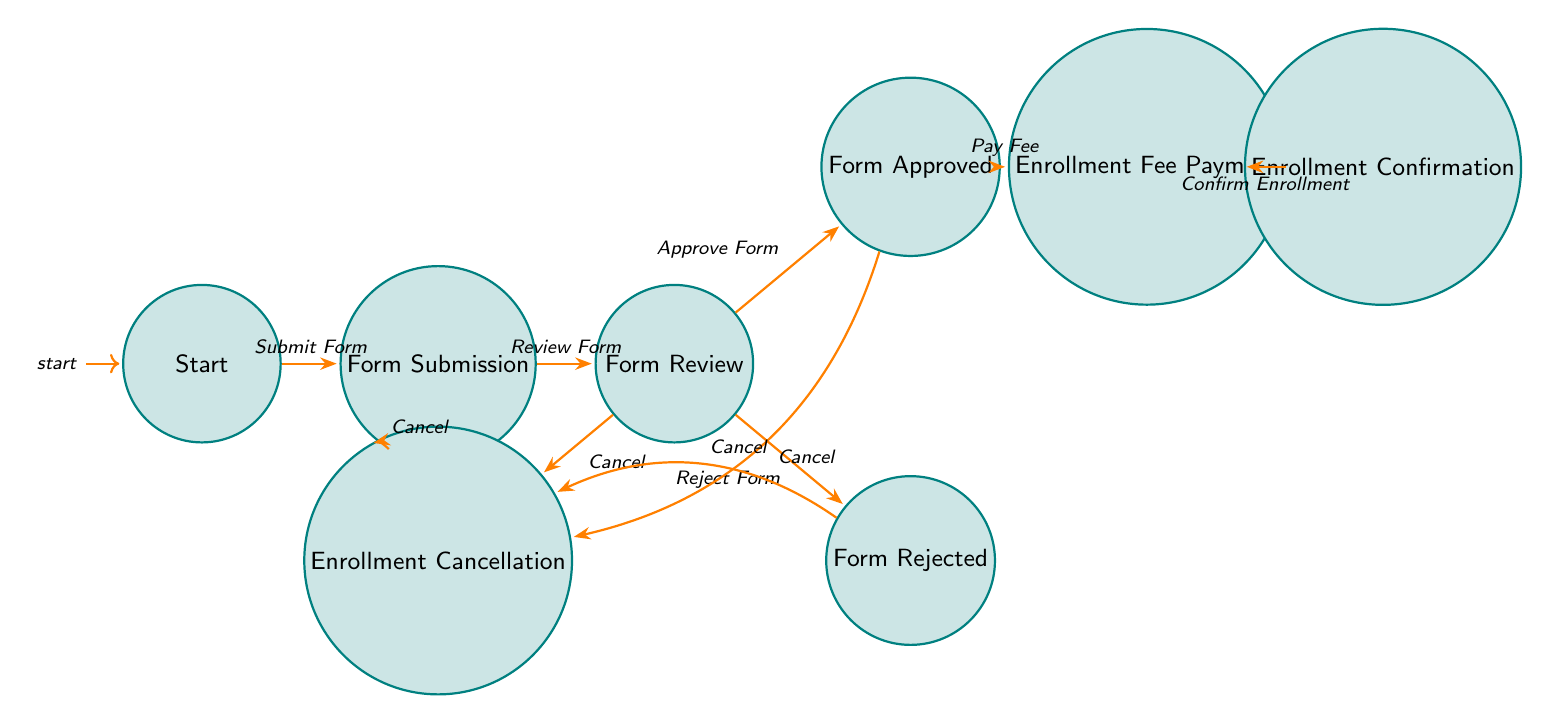What is the initial state of the enrollment process? The initial state is labeled "Start" in the diagram, indicating where the enrollment process begins.
Answer: Start How many states are present in the diagram? By counting the nodes in the diagram, we find there are a total of eight states.
Answer: 8 What event leads to the "Form Review" state? The event that leads to the "Form Review" is the "Review Form" action initiated after the form submission.
Answer: Review Form Which state leads to "Enrollment Confirmation"? The state that transitions to "Enrollment Confirmation" is "Enrollment Fee Payment" upon the "Confirm Enrollment" event.
Answer: Enrollment Fee Payment If a student cancels enrollment after "Form Submission", which state do they go to? If the student cancels enrollment, they move to the "Enrollment Cancellation" state from the "Form Submission" state.
Answer: Enrollment Cancellation What are the two outcomes after the "Form Review"? The two outcomes from the "Form Review" state are either "Form Approved" or "Form Rejected," depending on the teacher's decision.
Answer: Form Approved, Form Rejected What happens if the form is rejected? If the form is rejected, the student is directed to the "Enrollment Cancellation" state through the "Cancel Enrollment" event.
Answer: Enrollment Cancellation Is it possible to cancel enrollment from the "Form Approved" state? Yes, it's possible to cancel enrollment from the "Form Approved" state, leading to the "Enrollment Cancellation" state.
Answer: Yes 